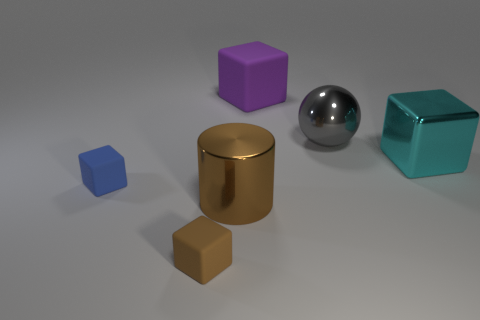Subtract all big cyan cubes. How many cubes are left? 3 Subtract all cyan blocks. How many blocks are left? 3 Subtract 1 brown blocks. How many objects are left? 5 Subtract all balls. How many objects are left? 5 Subtract 2 cubes. How many cubes are left? 2 Subtract all purple cylinders. Subtract all purple balls. How many cylinders are left? 1 Subtract all purple cylinders. How many brown cubes are left? 1 Subtract all big blue metal blocks. Subtract all large metal objects. How many objects are left? 3 Add 1 small cubes. How many small cubes are left? 3 Add 1 large green rubber balls. How many large green rubber balls exist? 1 